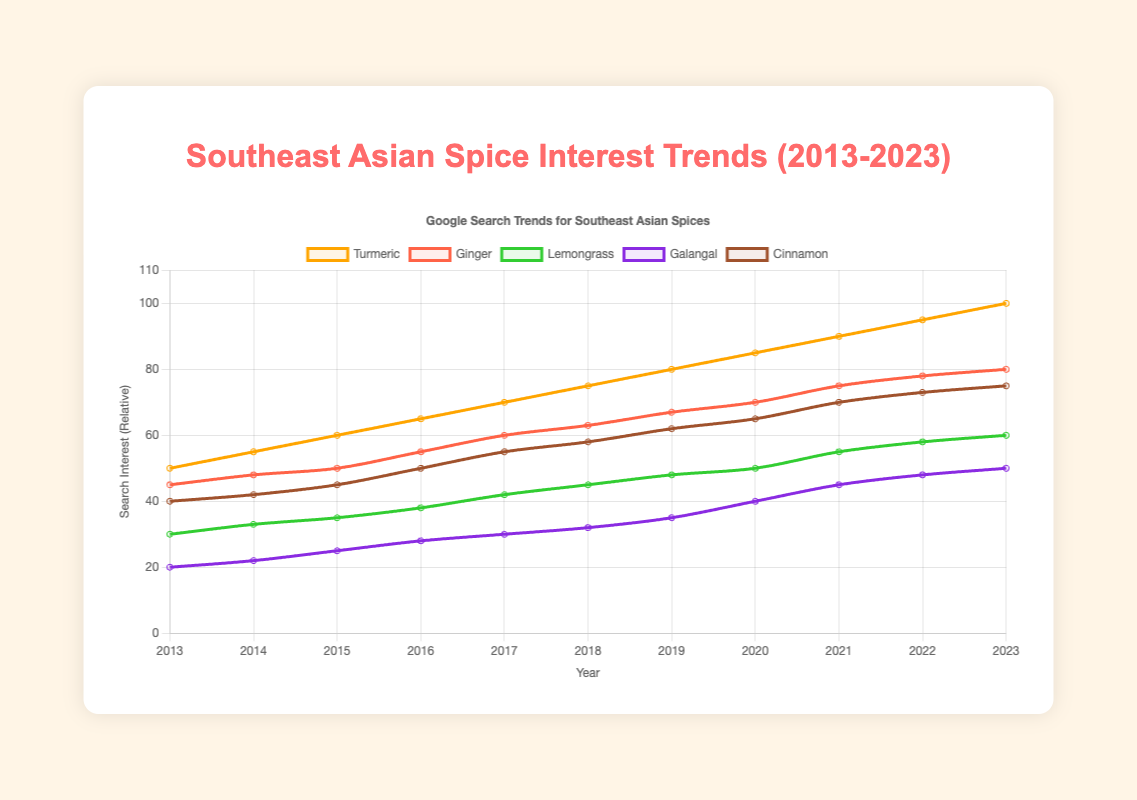Which spice had the highest increase in search interest from 2013 to 2023? To find the spice with the highest increase in search interest, we need to compare the interest values in 2013 and 2023 for each spice and calculate the difference. Turmeric increased by 50, Ginger by 35, Lemongrass by 30, Galangal by 30, and Cinnamon by 35. The highest increase is for Turmeric.
Answer: Turmeric How did the search interest in Lemongrass change between 2015 and 2020? Find the interest values for Lemongrass in 2015 and 2020 (35 and 50, respectively) and calculate the difference: 50 - 35 = 15.
Answer: Increased by 15 Which spice showed the slowest growth in search interest over the decade? We need to calculate the difference in search interest from 2013 to 2023 for all spices and identify the smallest difference. Galangal increased by 30, which is the smallest growth.
Answer: Galangal By how much did interest in Cinnamon grow between 2017 and 2021? Identify the interest values for Cinnamon in 2017 (55) and 2021 (70). Calculate the difference: 70 - 55 = 15.
Answer: 15 How does the interest in Ginger in 2020 compare to the interest in Turmeric in 2013? Find the interest values for Ginger in 2020 (70) and for Turmeric in 2013 (50). Compare the two values: 70 is greater than 50.
Answer: Greater What was the average yearly search interest for Galangal over the decade? Sum the search interest values for Galangal from 2013 to 2023: 20 + 22 + 25 + 28 + 30 + 32 + 35 + 40 + 45 + 48 + 50 = 375. Divide by the number of years (11): 375 / 11 ≈ 34.1.
Answer: 34.1 Which year saw the largest increase in search interest for Ginger compared to the previous year? Calculate the yearly differences for Ginger: 48-45=3 (2014), 50-48=2 (2015), 55-50=5 (2016), 60-55=5 (2017), 63-60=3 (2018), 67-63=4 (2019), 70-67=3 (2020), 75-70=5 (2021), 78-75=3 (2022), 80-78=2 (2023). The largest increases were seen in 2016, 2017, and 2021, all by 5 points.
Answer: 2016, 2017, 2021 What was the combined search interest for Turmeric and Cinnamon in 2015? Add the interest values for Turmeric (60) and Cinnamon (45) in 2015: 60 + 45 = 105.
Answer: 105 Compare the search interest for Lemongrass and Galangal in 2019. Which one was higher and by how much? Find the interest values for Lemongrass (48) and Galangal (35) in 2019. Lemongrass is higher by 48 - 35 = 13.
Answer: Lemongrass by 13 What was the visual trend for the search interest in Turmeric over the decade? Observing the line plot, the search interest for Turmeric shows a consistent upward trend from 2013 to 2023.
Answer: Upward trend 